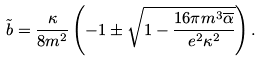<formula> <loc_0><loc_0><loc_500><loc_500>\tilde { b } = \frac { \kappa } { 8 m ^ { 2 } } \left ( - 1 \pm \sqrt { 1 - \frac { 1 6 \pi m ^ { 3 } \overline { \alpha } } { e ^ { 2 } \kappa ^ { 2 } } } \right ) .</formula> 